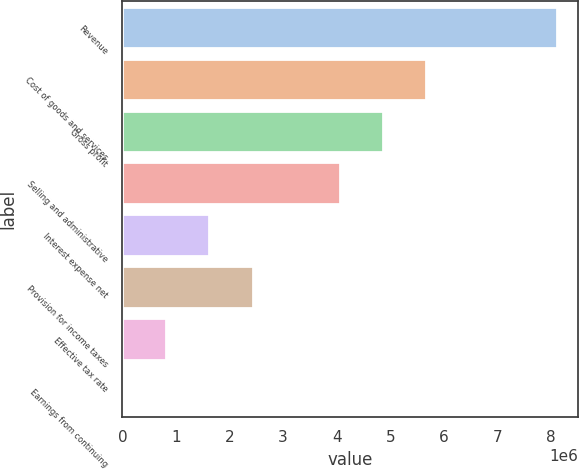<chart> <loc_0><loc_0><loc_500><loc_500><bar_chart><fcel>Revenue<fcel>Cost of goods and services<fcel>Gross profit<fcel>Selling and administrative<fcel>Interest expense net<fcel>Provision for income taxes<fcel>Effective tax rate<fcel>Earnings from continuing<nl><fcel>8.10434e+06<fcel>5.67304e+06<fcel>4.86261e+06<fcel>4.05217e+06<fcel>1.62087e+06<fcel>2.4313e+06<fcel>810438<fcel>4.53<nl></chart> 